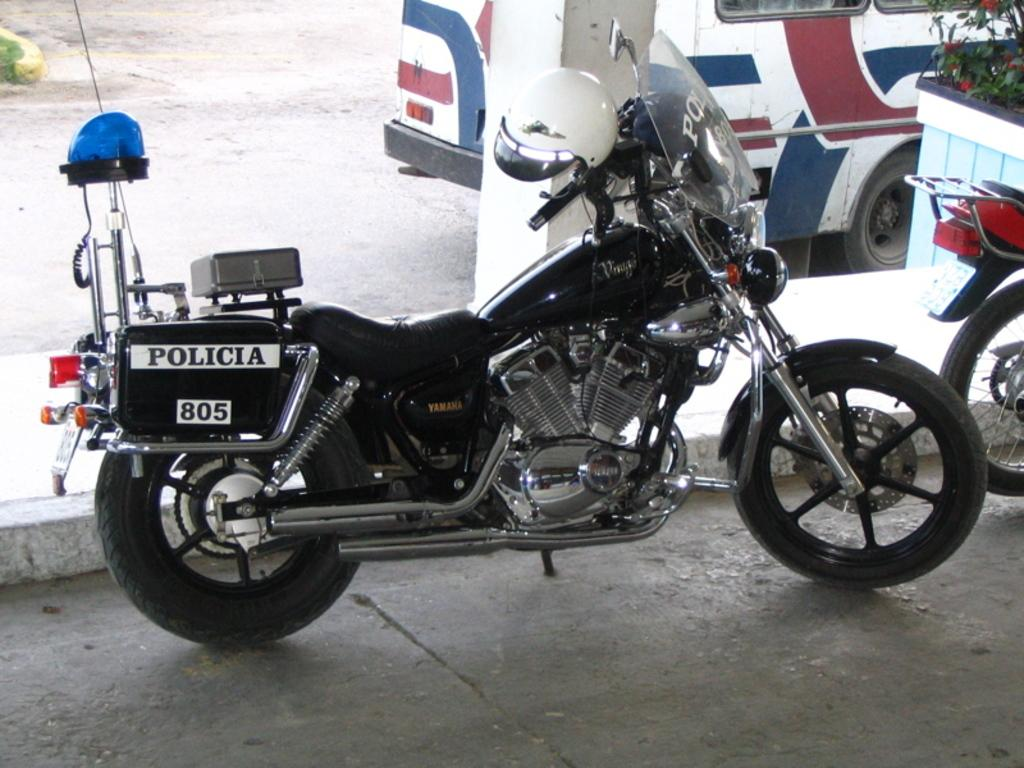What is the main subject in the center of the image? There is a bike in the center of the image on the road. Are there any other bikes visible in the image? Yes, there is another bike on the right side of the image. What type of vegetation is present on the right side of the image? There are plants and flowers on the right side of the image. What can be seen in the background of the image? There is a pillar, a bus, and a road in the background of the image. What type of cream can be seen in the pot on the left side of the image? There is no pot or cream present in the image. 